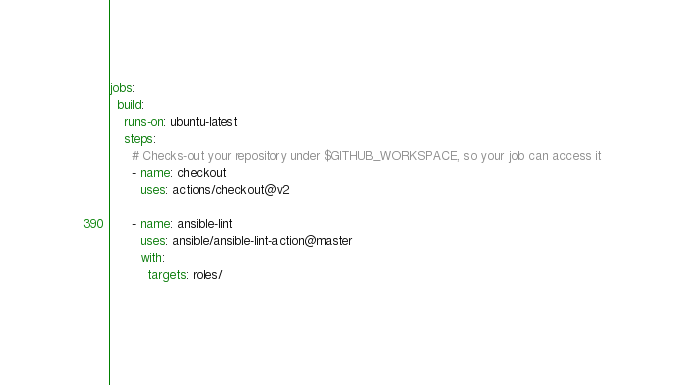Convert code to text. <code><loc_0><loc_0><loc_500><loc_500><_YAML_>jobs:
  build:
    runs-on: ubuntu-latest
    steps:
      # Checks-out your repository under $GITHUB_WORKSPACE, so your job can access it
      - name: checkout
        uses: actions/checkout@v2

      - name: ansible-lint
        uses: ansible/ansible-lint-action@master
        with:
          targets: roles/
            
</code> 